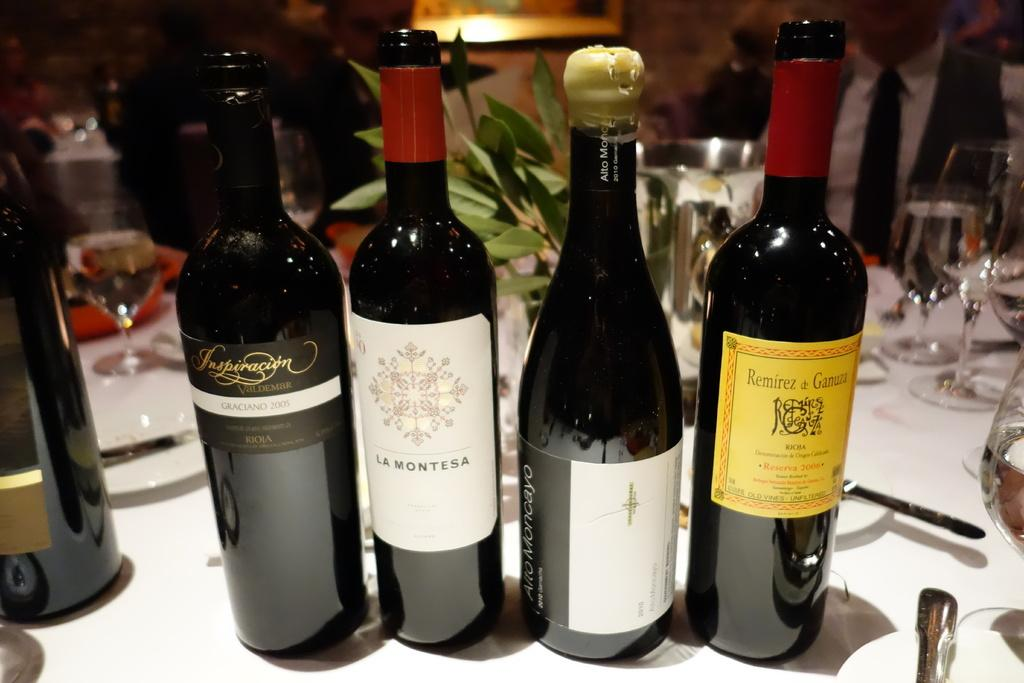<image>
Provide a brief description of the given image. A bottle of La Montesa is surrounded by other bottles. 